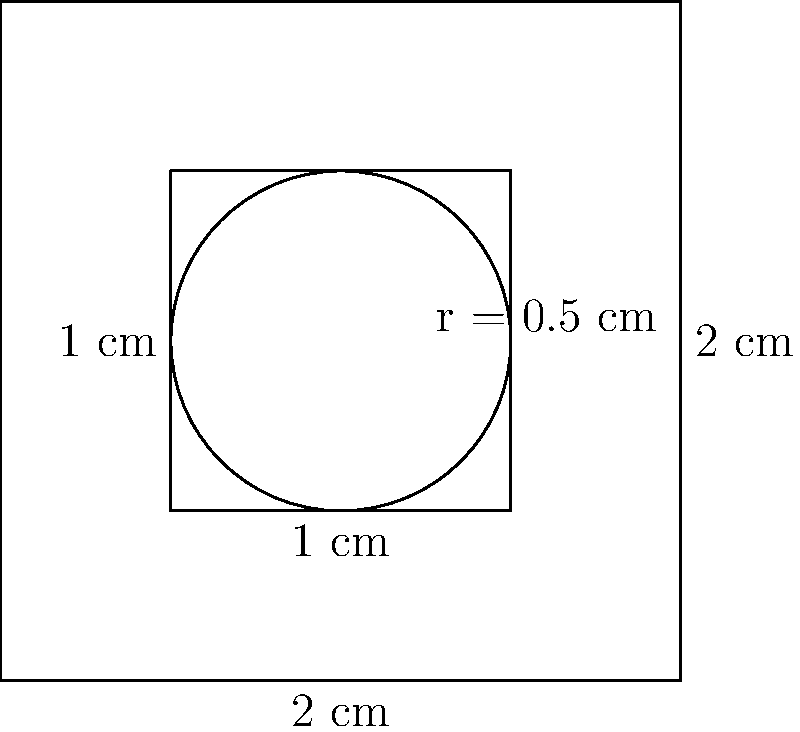In this intricate arabesque design inspired by illuminated manuscripts, calculate the perimeter of the entire shape. The outer square has sides of 2 cm, the inner square has sides of 1 cm, and there is a perfect circle in the center with a radius of 0.5 cm. How does this geometric interplay reflect the complexity often found in Arabic calligraphy and poetry? To calculate the perimeter of this arabesque design, we need to sum up the lengths of all outer edges. Let's break it down step-by-step:

1. Outer square:
   Perimeter of outer square = $4 \times 2 \text{ cm} = 8 \text{ cm}$

2. Inner square:
   We don't include the inner square in our calculation as it doesn't contribute to the outer perimeter.

3. Circle:
   Circumference of circle = $2\pi r = 2\pi \times 0.5 \text{ cm} = \pi \text{ cm}$

4. Total perimeter:
   Sum of outer square perimeter and circle circumference
   $= 8 \text{ cm} + \pi \text{ cm} = (8 + \pi) \text{ cm}$

This geometric interplay reflects the complexity of Arabic calligraphy and poetry through its layered structure and the combination of straight lines (representing structure and form in poetry) with curves (symbolizing the flow and rhythm of language). The precise measurements echo the metrical patterns in Arabic poetry, while the overall symmetry mirrors the balanced nature of well-crafted verses.
Answer: $(8 + \pi) \text{ cm}$ 